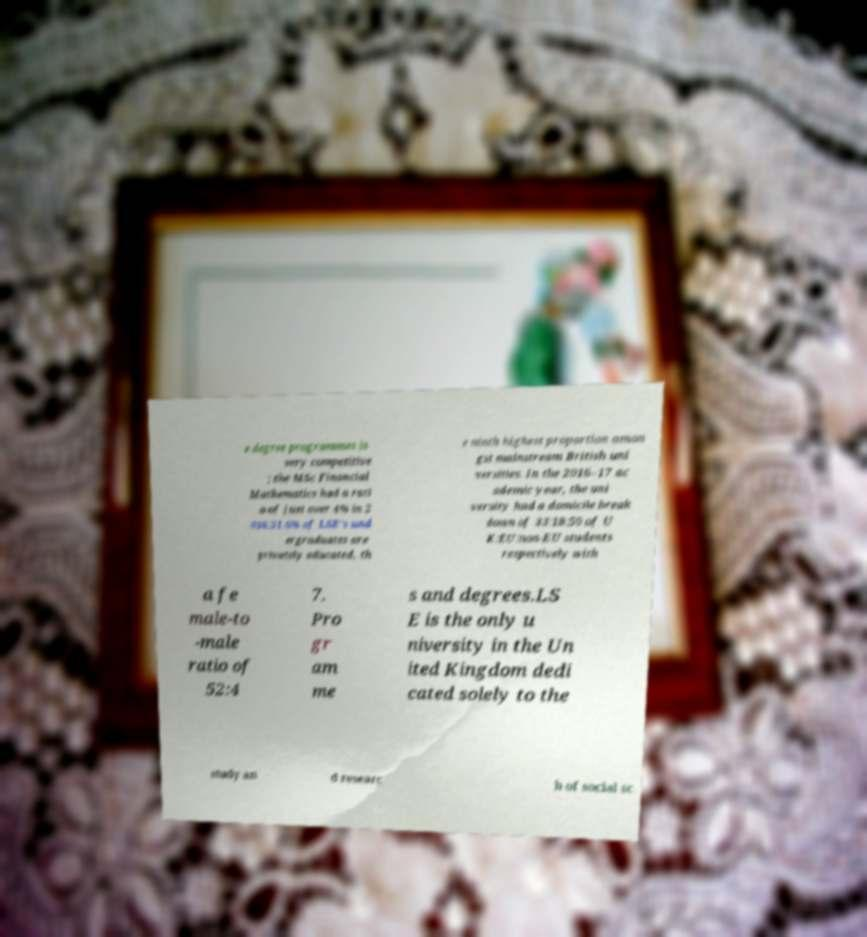Please identify and transcribe the text found in this image. e degree programmes is very competitive ; the MSc Financial Mathematics had a rati o of just over 4% in 2 016.31.6% of LSE's und ergraduates are privately educated, th e ninth highest proportion amon gst mainstream British uni versities. In the 2016–17 ac ademic year, the uni versity had a domicile break down of 33:18:50 of U K:EU:non-EU students respectively with a fe male-to -male ratio of 52:4 7. Pro gr am me s and degrees.LS E is the only u niversity in the Un ited Kingdom dedi cated solely to the study an d researc h of social sc 